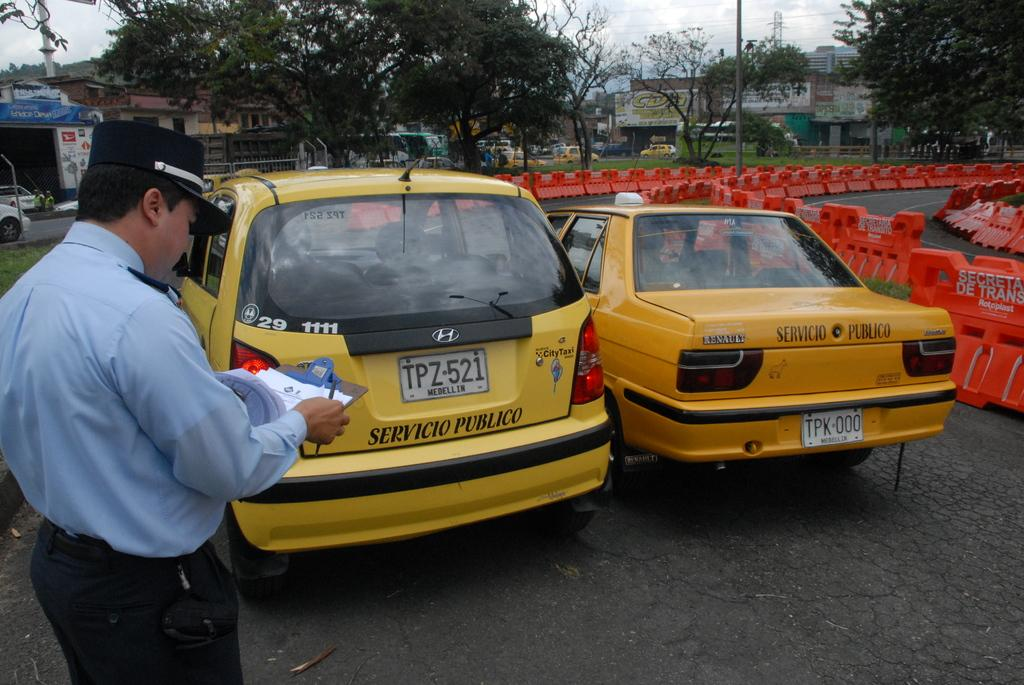<image>
Give a short and clear explanation of the subsequent image. A tellow servicio publico has a plate with TPZ521. 